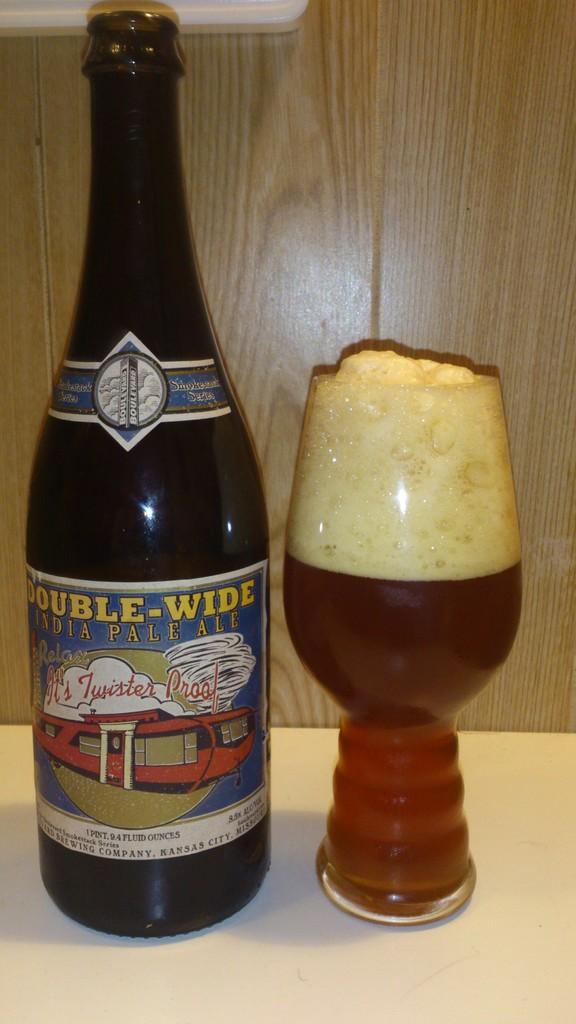Could you give a brief overview of what you see in this image? In this image we can see a bottle with a label. Near to the bottle there is a glass with a drink. In the back there is a wooden wall. 